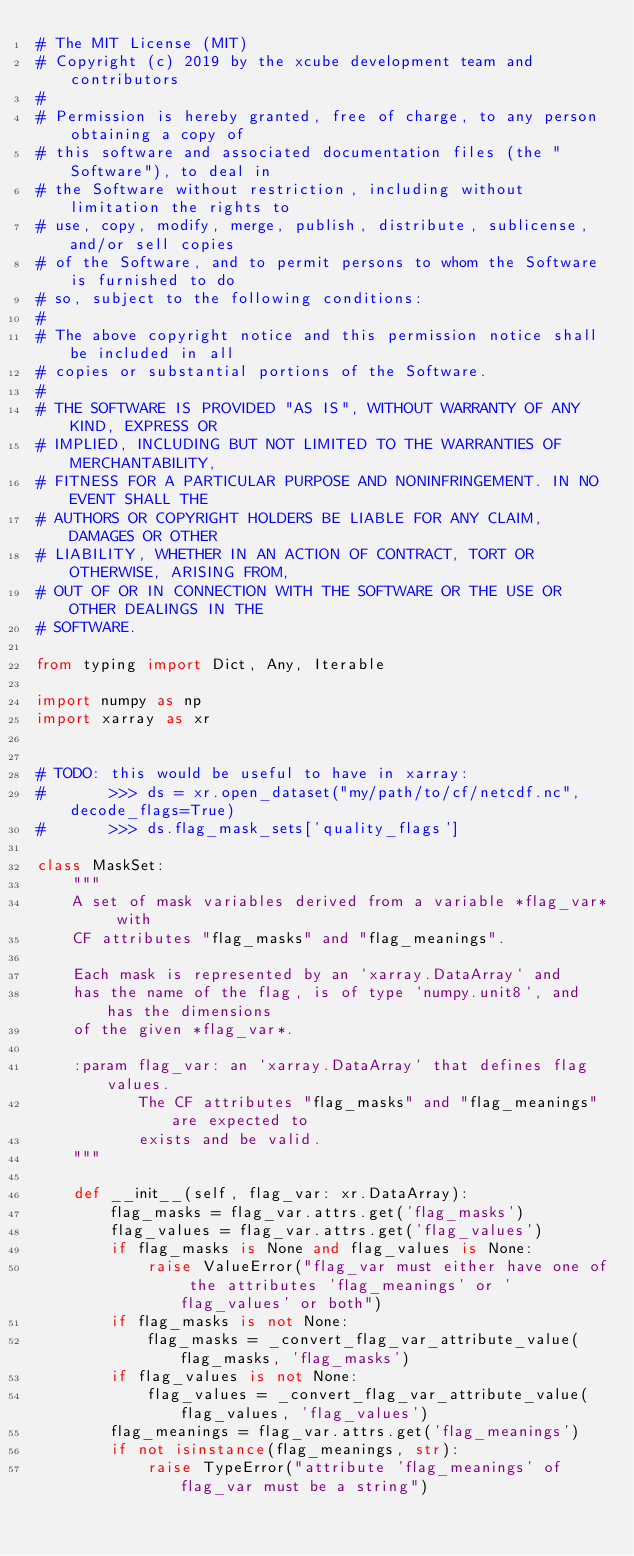<code> <loc_0><loc_0><loc_500><loc_500><_Python_># The MIT License (MIT)
# Copyright (c) 2019 by the xcube development team and contributors
#
# Permission is hereby granted, free of charge, to any person obtaining a copy of
# this software and associated documentation files (the "Software"), to deal in
# the Software without restriction, including without limitation the rights to
# use, copy, modify, merge, publish, distribute, sublicense, and/or sell copies
# of the Software, and to permit persons to whom the Software is furnished to do
# so, subject to the following conditions:
#
# The above copyright notice and this permission notice shall be included in all
# copies or substantial portions of the Software.
#
# THE SOFTWARE IS PROVIDED "AS IS", WITHOUT WARRANTY OF ANY KIND, EXPRESS OR
# IMPLIED, INCLUDING BUT NOT LIMITED TO THE WARRANTIES OF MERCHANTABILITY,
# FITNESS FOR A PARTICULAR PURPOSE AND NONINFRINGEMENT. IN NO EVENT SHALL THE
# AUTHORS OR COPYRIGHT HOLDERS BE LIABLE FOR ANY CLAIM, DAMAGES OR OTHER
# LIABILITY, WHETHER IN AN ACTION OF CONTRACT, TORT OR OTHERWISE, ARISING FROM,
# OUT OF OR IN CONNECTION WITH THE SOFTWARE OR THE USE OR OTHER DEALINGS IN THE
# SOFTWARE.

from typing import Dict, Any, Iterable

import numpy as np
import xarray as xr


# TODO: this would be useful to have in xarray:
#       >>> ds = xr.open_dataset("my/path/to/cf/netcdf.nc", decode_flags=True)
#       >>> ds.flag_mask_sets['quality_flags']

class MaskSet:
    """
    A set of mask variables derived from a variable *flag_var* with
    CF attributes "flag_masks" and "flag_meanings".

    Each mask is represented by an `xarray.DataArray` and
    has the name of the flag, is of type `numpy.unit8`, and has the dimensions
    of the given *flag_var*.

    :param flag_var: an `xarray.DataArray` that defines flag values.
           The CF attributes "flag_masks" and "flag_meanings" are expected to
           exists and be valid.
    """

    def __init__(self, flag_var: xr.DataArray):
        flag_masks = flag_var.attrs.get('flag_masks')
        flag_values = flag_var.attrs.get('flag_values')
        if flag_masks is None and flag_values is None:
            raise ValueError("flag_var must either have one of the attributes 'flag_meanings' or 'flag_values' or both")
        if flag_masks is not None:
            flag_masks = _convert_flag_var_attribute_value(flag_masks, 'flag_masks')
        if flag_values is not None:
            flag_values = _convert_flag_var_attribute_value(flag_values, 'flag_values')
        flag_meanings = flag_var.attrs.get('flag_meanings')
        if not isinstance(flag_meanings, str):
            raise TypeError("attribute 'flag_meanings' of flag_var must be a string")</code> 